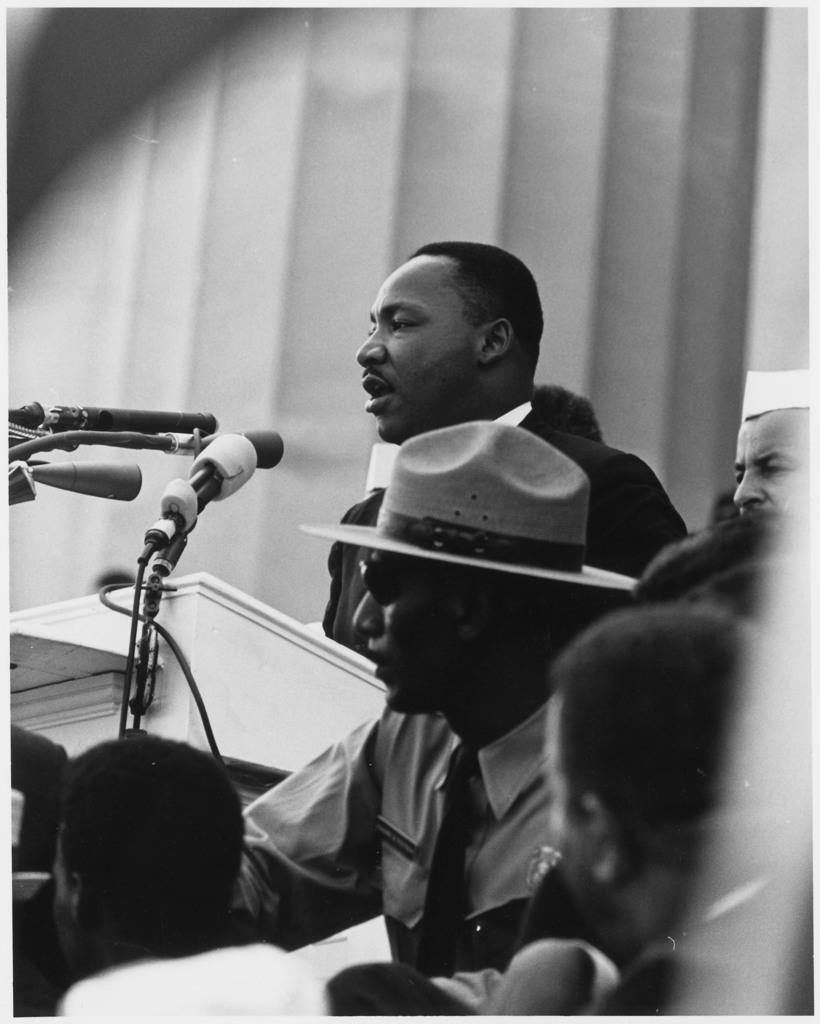What is the color scheme of the image? The image is black and white. Who or what can be seen in the image? There are people in the image. What objects are present in the image that might be used for amplifying sound? There are microphones (mikes) in the image. What structure is visible in the image that might be used for presentations or speeches? There is a podium in the image. What is visible in the background of the image? There is a wall in the background of the image. What type of street is visible in the image? There is no street visible in the image; it is set against a wall in the background. What type of pleasure can be seen being derived from the microphones in the image? There is no indication of pleasure in the image; it simply shows people with microphones and a podium. 